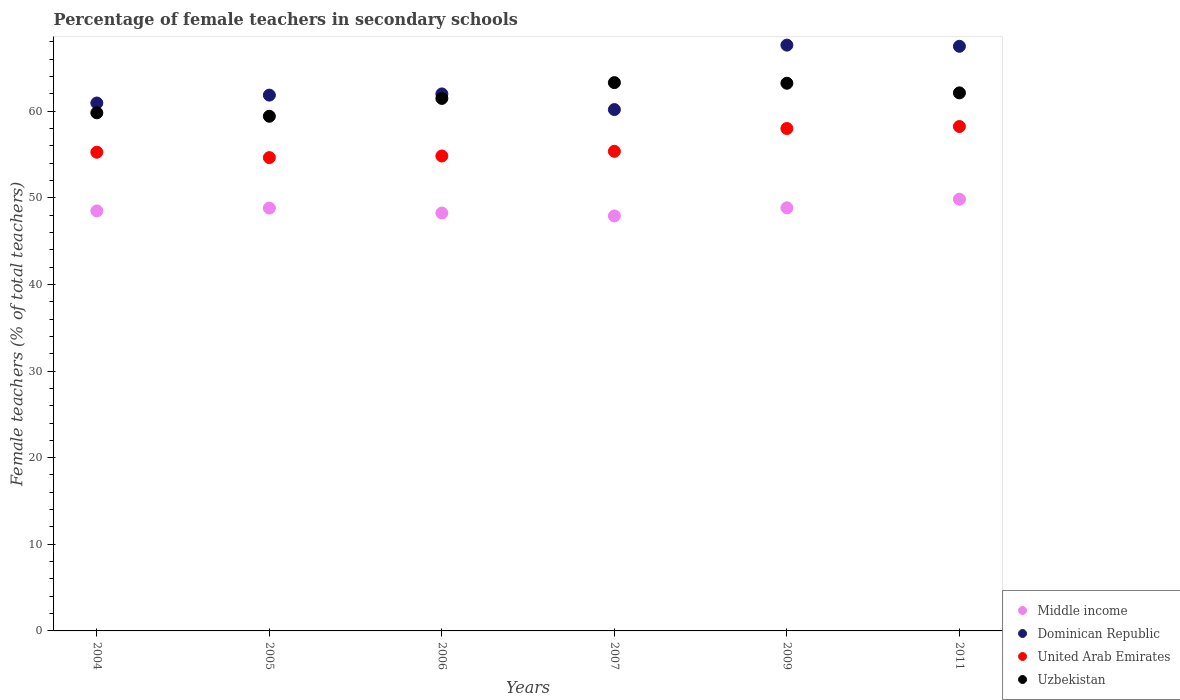How many different coloured dotlines are there?
Your answer should be compact. 4. Is the number of dotlines equal to the number of legend labels?
Your response must be concise. Yes. What is the percentage of female teachers in Middle income in 2007?
Offer a very short reply. 47.9. Across all years, what is the maximum percentage of female teachers in Uzbekistan?
Keep it short and to the point. 63.29. Across all years, what is the minimum percentage of female teachers in Dominican Republic?
Give a very brief answer. 60.18. In which year was the percentage of female teachers in Uzbekistan minimum?
Offer a terse response. 2005. What is the total percentage of female teachers in Uzbekistan in the graph?
Keep it short and to the point. 369.3. What is the difference between the percentage of female teachers in Uzbekistan in 2006 and that in 2007?
Your response must be concise. -1.82. What is the difference between the percentage of female teachers in Dominican Republic in 2011 and the percentage of female teachers in Middle income in 2005?
Make the answer very short. 18.68. What is the average percentage of female teachers in Dominican Republic per year?
Provide a succinct answer. 63.34. In the year 2011, what is the difference between the percentage of female teachers in Middle income and percentage of female teachers in Uzbekistan?
Your response must be concise. -12.27. What is the ratio of the percentage of female teachers in Middle income in 2006 to that in 2009?
Offer a terse response. 0.99. Is the percentage of female teachers in Dominican Republic in 2004 less than that in 2007?
Offer a terse response. No. Is the difference between the percentage of female teachers in Middle income in 2004 and 2011 greater than the difference between the percentage of female teachers in Uzbekistan in 2004 and 2011?
Give a very brief answer. Yes. What is the difference between the highest and the second highest percentage of female teachers in Middle income?
Offer a terse response. 1. What is the difference between the highest and the lowest percentage of female teachers in Dominican Republic?
Provide a succinct answer. 7.44. In how many years, is the percentage of female teachers in Middle income greater than the average percentage of female teachers in Middle income taken over all years?
Make the answer very short. 3. Is it the case that in every year, the sum of the percentage of female teachers in Dominican Republic and percentage of female teachers in United Arab Emirates  is greater than the percentage of female teachers in Middle income?
Your response must be concise. Yes. Does the percentage of female teachers in United Arab Emirates monotonically increase over the years?
Ensure brevity in your answer.  No. How many dotlines are there?
Your answer should be very brief. 4. How many years are there in the graph?
Make the answer very short. 6. What is the difference between two consecutive major ticks on the Y-axis?
Offer a terse response. 10. Does the graph contain any zero values?
Give a very brief answer. No. What is the title of the graph?
Your response must be concise. Percentage of female teachers in secondary schools. What is the label or title of the X-axis?
Ensure brevity in your answer.  Years. What is the label or title of the Y-axis?
Your answer should be very brief. Female teachers (% of total teachers). What is the Female teachers (% of total teachers) of Middle income in 2004?
Your response must be concise. 48.48. What is the Female teachers (% of total teachers) in Dominican Republic in 2004?
Make the answer very short. 60.94. What is the Female teachers (% of total teachers) of United Arab Emirates in 2004?
Make the answer very short. 55.26. What is the Female teachers (% of total teachers) of Uzbekistan in 2004?
Ensure brevity in your answer.  59.81. What is the Female teachers (% of total teachers) in Middle income in 2005?
Offer a very short reply. 48.81. What is the Female teachers (% of total teachers) of Dominican Republic in 2005?
Your response must be concise. 61.85. What is the Female teachers (% of total teachers) of United Arab Emirates in 2005?
Your response must be concise. 54.64. What is the Female teachers (% of total teachers) in Uzbekistan in 2005?
Offer a terse response. 59.41. What is the Female teachers (% of total teachers) in Middle income in 2006?
Provide a succinct answer. 48.24. What is the Female teachers (% of total teachers) in Dominican Republic in 2006?
Offer a terse response. 61.99. What is the Female teachers (% of total teachers) of United Arab Emirates in 2006?
Keep it short and to the point. 54.82. What is the Female teachers (% of total teachers) of Uzbekistan in 2006?
Your response must be concise. 61.47. What is the Female teachers (% of total teachers) of Middle income in 2007?
Provide a short and direct response. 47.9. What is the Female teachers (% of total teachers) in Dominican Republic in 2007?
Offer a terse response. 60.18. What is the Female teachers (% of total teachers) of United Arab Emirates in 2007?
Offer a very short reply. 55.36. What is the Female teachers (% of total teachers) in Uzbekistan in 2007?
Ensure brevity in your answer.  63.29. What is the Female teachers (% of total teachers) in Middle income in 2009?
Provide a short and direct response. 48.84. What is the Female teachers (% of total teachers) of Dominican Republic in 2009?
Provide a short and direct response. 67.62. What is the Female teachers (% of total teachers) in United Arab Emirates in 2009?
Provide a succinct answer. 58. What is the Female teachers (% of total teachers) of Uzbekistan in 2009?
Ensure brevity in your answer.  63.22. What is the Female teachers (% of total teachers) of Middle income in 2011?
Offer a terse response. 49.84. What is the Female teachers (% of total teachers) of Dominican Republic in 2011?
Your answer should be very brief. 67.48. What is the Female teachers (% of total teachers) in United Arab Emirates in 2011?
Give a very brief answer. 58.23. What is the Female teachers (% of total teachers) in Uzbekistan in 2011?
Your response must be concise. 62.11. Across all years, what is the maximum Female teachers (% of total teachers) of Middle income?
Make the answer very short. 49.84. Across all years, what is the maximum Female teachers (% of total teachers) in Dominican Republic?
Ensure brevity in your answer.  67.62. Across all years, what is the maximum Female teachers (% of total teachers) in United Arab Emirates?
Your answer should be compact. 58.23. Across all years, what is the maximum Female teachers (% of total teachers) of Uzbekistan?
Give a very brief answer. 63.29. Across all years, what is the minimum Female teachers (% of total teachers) of Middle income?
Your answer should be very brief. 47.9. Across all years, what is the minimum Female teachers (% of total teachers) of Dominican Republic?
Keep it short and to the point. 60.18. Across all years, what is the minimum Female teachers (% of total teachers) of United Arab Emirates?
Your answer should be compact. 54.64. Across all years, what is the minimum Female teachers (% of total teachers) of Uzbekistan?
Give a very brief answer. 59.41. What is the total Female teachers (% of total teachers) of Middle income in the graph?
Give a very brief answer. 292.1. What is the total Female teachers (% of total teachers) of Dominican Republic in the graph?
Provide a short and direct response. 380.06. What is the total Female teachers (% of total teachers) in United Arab Emirates in the graph?
Keep it short and to the point. 336.3. What is the total Female teachers (% of total teachers) of Uzbekistan in the graph?
Give a very brief answer. 369.3. What is the difference between the Female teachers (% of total teachers) of Middle income in 2004 and that in 2005?
Ensure brevity in your answer.  -0.32. What is the difference between the Female teachers (% of total teachers) of Dominican Republic in 2004 and that in 2005?
Make the answer very short. -0.91. What is the difference between the Female teachers (% of total teachers) in United Arab Emirates in 2004 and that in 2005?
Offer a terse response. 0.62. What is the difference between the Female teachers (% of total teachers) of Uzbekistan in 2004 and that in 2005?
Your answer should be compact. 0.4. What is the difference between the Female teachers (% of total teachers) of Middle income in 2004 and that in 2006?
Your answer should be compact. 0.24. What is the difference between the Female teachers (% of total teachers) of Dominican Republic in 2004 and that in 2006?
Provide a succinct answer. -1.05. What is the difference between the Female teachers (% of total teachers) of United Arab Emirates in 2004 and that in 2006?
Ensure brevity in your answer.  0.44. What is the difference between the Female teachers (% of total teachers) of Uzbekistan in 2004 and that in 2006?
Your answer should be compact. -1.66. What is the difference between the Female teachers (% of total teachers) of Middle income in 2004 and that in 2007?
Offer a terse response. 0.58. What is the difference between the Female teachers (% of total teachers) in Dominican Republic in 2004 and that in 2007?
Make the answer very short. 0.76. What is the difference between the Female teachers (% of total teachers) of United Arab Emirates in 2004 and that in 2007?
Your answer should be compact. -0.1. What is the difference between the Female teachers (% of total teachers) in Uzbekistan in 2004 and that in 2007?
Offer a very short reply. -3.48. What is the difference between the Female teachers (% of total teachers) in Middle income in 2004 and that in 2009?
Provide a succinct answer. -0.36. What is the difference between the Female teachers (% of total teachers) of Dominican Republic in 2004 and that in 2009?
Offer a very short reply. -6.68. What is the difference between the Female teachers (% of total teachers) in United Arab Emirates in 2004 and that in 2009?
Make the answer very short. -2.74. What is the difference between the Female teachers (% of total teachers) of Uzbekistan in 2004 and that in 2009?
Provide a succinct answer. -3.41. What is the difference between the Female teachers (% of total teachers) in Middle income in 2004 and that in 2011?
Provide a short and direct response. -1.35. What is the difference between the Female teachers (% of total teachers) in Dominican Republic in 2004 and that in 2011?
Your answer should be compact. -6.55. What is the difference between the Female teachers (% of total teachers) in United Arab Emirates in 2004 and that in 2011?
Your response must be concise. -2.97. What is the difference between the Female teachers (% of total teachers) in Uzbekistan in 2004 and that in 2011?
Your answer should be compact. -2.3. What is the difference between the Female teachers (% of total teachers) of Middle income in 2005 and that in 2006?
Offer a very short reply. 0.57. What is the difference between the Female teachers (% of total teachers) in Dominican Republic in 2005 and that in 2006?
Provide a short and direct response. -0.14. What is the difference between the Female teachers (% of total teachers) in United Arab Emirates in 2005 and that in 2006?
Offer a very short reply. -0.19. What is the difference between the Female teachers (% of total teachers) in Uzbekistan in 2005 and that in 2006?
Keep it short and to the point. -2.06. What is the difference between the Female teachers (% of total teachers) in Middle income in 2005 and that in 2007?
Your answer should be compact. 0.9. What is the difference between the Female teachers (% of total teachers) of Dominican Republic in 2005 and that in 2007?
Make the answer very short. 1.67. What is the difference between the Female teachers (% of total teachers) in United Arab Emirates in 2005 and that in 2007?
Make the answer very short. -0.73. What is the difference between the Female teachers (% of total teachers) of Uzbekistan in 2005 and that in 2007?
Offer a very short reply. -3.88. What is the difference between the Female teachers (% of total teachers) of Middle income in 2005 and that in 2009?
Keep it short and to the point. -0.03. What is the difference between the Female teachers (% of total teachers) in Dominican Republic in 2005 and that in 2009?
Provide a short and direct response. -5.77. What is the difference between the Female teachers (% of total teachers) of United Arab Emirates in 2005 and that in 2009?
Give a very brief answer. -3.36. What is the difference between the Female teachers (% of total teachers) of Uzbekistan in 2005 and that in 2009?
Your answer should be compact. -3.81. What is the difference between the Female teachers (% of total teachers) of Middle income in 2005 and that in 2011?
Provide a short and direct response. -1.03. What is the difference between the Female teachers (% of total teachers) of Dominican Republic in 2005 and that in 2011?
Offer a very short reply. -5.64. What is the difference between the Female teachers (% of total teachers) in United Arab Emirates in 2005 and that in 2011?
Keep it short and to the point. -3.59. What is the difference between the Female teachers (% of total teachers) in Uzbekistan in 2005 and that in 2011?
Ensure brevity in your answer.  -2.7. What is the difference between the Female teachers (% of total teachers) in Middle income in 2006 and that in 2007?
Ensure brevity in your answer.  0.34. What is the difference between the Female teachers (% of total teachers) in Dominican Republic in 2006 and that in 2007?
Give a very brief answer. 1.81. What is the difference between the Female teachers (% of total teachers) in United Arab Emirates in 2006 and that in 2007?
Your answer should be very brief. -0.54. What is the difference between the Female teachers (% of total teachers) in Uzbekistan in 2006 and that in 2007?
Offer a very short reply. -1.82. What is the difference between the Female teachers (% of total teachers) of Middle income in 2006 and that in 2009?
Give a very brief answer. -0.6. What is the difference between the Female teachers (% of total teachers) in Dominican Republic in 2006 and that in 2009?
Keep it short and to the point. -5.63. What is the difference between the Female teachers (% of total teachers) in United Arab Emirates in 2006 and that in 2009?
Offer a very short reply. -3.17. What is the difference between the Female teachers (% of total teachers) of Uzbekistan in 2006 and that in 2009?
Your response must be concise. -1.75. What is the difference between the Female teachers (% of total teachers) in Middle income in 2006 and that in 2011?
Ensure brevity in your answer.  -1.6. What is the difference between the Female teachers (% of total teachers) in Dominican Republic in 2006 and that in 2011?
Make the answer very short. -5.5. What is the difference between the Female teachers (% of total teachers) in United Arab Emirates in 2006 and that in 2011?
Make the answer very short. -3.4. What is the difference between the Female teachers (% of total teachers) in Uzbekistan in 2006 and that in 2011?
Your answer should be very brief. -0.64. What is the difference between the Female teachers (% of total teachers) of Middle income in 2007 and that in 2009?
Keep it short and to the point. -0.94. What is the difference between the Female teachers (% of total teachers) of Dominican Republic in 2007 and that in 2009?
Your answer should be very brief. -7.44. What is the difference between the Female teachers (% of total teachers) of United Arab Emirates in 2007 and that in 2009?
Offer a very short reply. -2.63. What is the difference between the Female teachers (% of total teachers) in Uzbekistan in 2007 and that in 2009?
Make the answer very short. 0.07. What is the difference between the Female teachers (% of total teachers) of Middle income in 2007 and that in 2011?
Provide a succinct answer. -1.93. What is the difference between the Female teachers (% of total teachers) of Dominican Republic in 2007 and that in 2011?
Provide a short and direct response. -7.3. What is the difference between the Female teachers (% of total teachers) of United Arab Emirates in 2007 and that in 2011?
Provide a short and direct response. -2.86. What is the difference between the Female teachers (% of total teachers) in Uzbekistan in 2007 and that in 2011?
Give a very brief answer. 1.18. What is the difference between the Female teachers (% of total teachers) of Middle income in 2009 and that in 2011?
Make the answer very short. -1. What is the difference between the Female teachers (% of total teachers) of Dominican Republic in 2009 and that in 2011?
Offer a terse response. 0.14. What is the difference between the Female teachers (% of total teachers) in United Arab Emirates in 2009 and that in 2011?
Your answer should be very brief. -0.23. What is the difference between the Female teachers (% of total teachers) in Uzbekistan in 2009 and that in 2011?
Offer a very short reply. 1.11. What is the difference between the Female teachers (% of total teachers) in Middle income in 2004 and the Female teachers (% of total teachers) in Dominican Republic in 2005?
Your answer should be very brief. -13.37. What is the difference between the Female teachers (% of total teachers) of Middle income in 2004 and the Female teachers (% of total teachers) of United Arab Emirates in 2005?
Offer a terse response. -6.15. What is the difference between the Female teachers (% of total teachers) in Middle income in 2004 and the Female teachers (% of total teachers) in Uzbekistan in 2005?
Ensure brevity in your answer.  -10.93. What is the difference between the Female teachers (% of total teachers) in Dominican Republic in 2004 and the Female teachers (% of total teachers) in United Arab Emirates in 2005?
Offer a terse response. 6.3. What is the difference between the Female teachers (% of total teachers) of Dominican Republic in 2004 and the Female teachers (% of total teachers) of Uzbekistan in 2005?
Make the answer very short. 1.53. What is the difference between the Female teachers (% of total teachers) of United Arab Emirates in 2004 and the Female teachers (% of total teachers) of Uzbekistan in 2005?
Your answer should be compact. -4.15. What is the difference between the Female teachers (% of total teachers) in Middle income in 2004 and the Female teachers (% of total teachers) in Dominican Republic in 2006?
Your answer should be very brief. -13.51. What is the difference between the Female teachers (% of total teachers) of Middle income in 2004 and the Female teachers (% of total teachers) of United Arab Emirates in 2006?
Your response must be concise. -6.34. What is the difference between the Female teachers (% of total teachers) in Middle income in 2004 and the Female teachers (% of total teachers) in Uzbekistan in 2006?
Ensure brevity in your answer.  -12.99. What is the difference between the Female teachers (% of total teachers) in Dominican Republic in 2004 and the Female teachers (% of total teachers) in United Arab Emirates in 2006?
Your answer should be very brief. 6.11. What is the difference between the Female teachers (% of total teachers) in Dominican Republic in 2004 and the Female teachers (% of total teachers) in Uzbekistan in 2006?
Give a very brief answer. -0.53. What is the difference between the Female teachers (% of total teachers) of United Arab Emirates in 2004 and the Female teachers (% of total teachers) of Uzbekistan in 2006?
Your answer should be very brief. -6.21. What is the difference between the Female teachers (% of total teachers) in Middle income in 2004 and the Female teachers (% of total teachers) in Dominican Republic in 2007?
Offer a very short reply. -11.7. What is the difference between the Female teachers (% of total teachers) in Middle income in 2004 and the Female teachers (% of total teachers) in United Arab Emirates in 2007?
Offer a very short reply. -6.88. What is the difference between the Female teachers (% of total teachers) in Middle income in 2004 and the Female teachers (% of total teachers) in Uzbekistan in 2007?
Keep it short and to the point. -14.81. What is the difference between the Female teachers (% of total teachers) in Dominican Republic in 2004 and the Female teachers (% of total teachers) in United Arab Emirates in 2007?
Keep it short and to the point. 5.58. What is the difference between the Female teachers (% of total teachers) in Dominican Republic in 2004 and the Female teachers (% of total teachers) in Uzbekistan in 2007?
Your answer should be very brief. -2.35. What is the difference between the Female teachers (% of total teachers) in United Arab Emirates in 2004 and the Female teachers (% of total teachers) in Uzbekistan in 2007?
Make the answer very short. -8.03. What is the difference between the Female teachers (% of total teachers) of Middle income in 2004 and the Female teachers (% of total teachers) of Dominican Republic in 2009?
Offer a very short reply. -19.14. What is the difference between the Female teachers (% of total teachers) in Middle income in 2004 and the Female teachers (% of total teachers) in United Arab Emirates in 2009?
Your response must be concise. -9.51. What is the difference between the Female teachers (% of total teachers) of Middle income in 2004 and the Female teachers (% of total teachers) of Uzbekistan in 2009?
Make the answer very short. -14.74. What is the difference between the Female teachers (% of total teachers) of Dominican Republic in 2004 and the Female teachers (% of total teachers) of United Arab Emirates in 2009?
Ensure brevity in your answer.  2.94. What is the difference between the Female teachers (% of total teachers) in Dominican Republic in 2004 and the Female teachers (% of total teachers) in Uzbekistan in 2009?
Provide a short and direct response. -2.28. What is the difference between the Female teachers (% of total teachers) of United Arab Emirates in 2004 and the Female teachers (% of total teachers) of Uzbekistan in 2009?
Offer a very short reply. -7.96. What is the difference between the Female teachers (% of total teachers) of Middle income in 2004 and the Female teachers (% of total teachers) of Dominican Republic in 2011?
Provide a short and direct response. -19. What is the difference between the Female teachers (% of total teachers) in Middle income in 2004 and the Female teachers (% of total teachers) in United Arab Emirates in 2011?
Give a very brief answer. -9.74. What is the difference between the Female teachers (% of total teachers) in Middle income in 2004 and the Female teachers (% of total teachers) in Uzbekistan in 2011?
Ensure brevity in your answer.  -13.63. What is the difference between the Female teachers (% of total teachers) in Dominican Republic in 2004 and the Female teachers (% of total teachers) in United Arab Emirates in 2011?
Offer a very short reply. 2.71. What is the difference between the Female teachers (% of total teachers) of Dominican Republic in 2004 and the Female teachers (% of total teachers) of Uzbekistan in 2011?
Make the answer very short. -1.17. What is the difference between the Female teachers (% of total teachers) of United Arab Emirates in 2004 and the Female teachers (% of total teachers) of Uzbekistan in 2011?
Offer a terse response. -6.85. What is the difference between the Female teachers (% of total teachers) of Middle income in 2005 and the Female teachers (% of total teachers) of Dominican Republic in 2006?
Provide a short and direct response. -13.18. What is the difference between the Female teachers (% of total teachers) of Middle income in 2005 and the Female teachers (% of total teachers) of United Arab Emirates in 2006?
Ensure brevity in your answer.  -6.02. What is the difference between the Female teachers (% of total teachers) of Middle income in 2005 and the Female teachers (% of total teachers) of Uzbekistan in 2006?
Provide a succinct answer. -12.66. What is the difference between the Female teachers (% of total teachers) in Dominican Republic in 2005 and the Female teachers (% of total teachers) in United Arab Emirates in 2006?
Your answer should be very brief. 7.03. What is the difference between the Female teachers (% of total teachers) in Dominican Republic in 2005 and the Female teachers (% of total teachers) in Uzbekistan in 2006?
Make the answer very short. 0.38. What is the difference between the Female teachers (% of total teachers) in United Arab Emirates in 2005 and the Female teachers (% of total teachers) in Uzbekistan in 2006?
Offer a very short reply. -6.83. What is the difference between the Female teachers (% of total teachers) of Middle income in 2005 and the Female teachers (% of total teachers) of Dominican Republic in 2007?
Offer a terse response. -11.37. What is the difference between the Female teachers (% of total teachers) of Middle income in 2005 and the Female teachers (% of total teachers) of United Arab Emirates in 2007?
Provide a short and direct response. -6.56. What is the difference between the Female teachers (% of total teachers) in Middle income in 2005 and the Female teachers (% of total teachers) in Uzbekistan in 2007?
Offer a very short reply. -14.48. What is the difference between the Female teachers (% of total teachers) in Dominican Republic in 2005 and the Female teachers (% of total teachers) in United Arab Emirates in 2007?
Your response must be concise. 6.49. What is the difference between the Female teachers (% of total teachers) in Dominican Republic in 2005 and the Female teachers (% of total teachers) in Uzbekistan in 2007?
Make the answer very short. -1.44. What is the difference between the Female teachers (% of total teachers) in United Arab Emirates in 2005 and the Female teachers (% of total teachers) in Uzbekistan in 2007?
Make the answer very short. -8.65. What is the difference between the Female teachers (% of total teachers) in Middle income in 2005 and the Female teachers (% of total teachers) in Dominican Republic in 2009?
Ensure brevity in your answer.  -18.81. What is the difference between the Female teachers (% of total teachers) in Middle income in 2005 and the Female teachers (% of total teachers) in United Arab Emirates in 2009?
Offer a terse response. -9.19. What is the difference between the Female teachers (% of total teachers) in Middle income in 2005 and the Female teachers (% of total teachers) in Uzbekistan in 2009?
Keep it short and to the point. -14.41. What is the difference between the Female teachers (% of total teachers) in Dominican Republic in 2005 and the Female teachers (% of total teachers) in United Arab Emirates in 2009?
Offer a terse response. 3.85. What is the difference between the Female teachers (% of total teachers) in Dominican Republic in 2005 and the Female teachers (% of total teachers) in Uzbekistan in 2009?
Your answer should be very brief. -1.37. What is the difference between the Female teachers (% of total teachers) of United Arab Emirates in 2005 and the Female teachers (% of total teachers) of Uzbekistan in 2009?
Ensure brevity in your answer.  -8.58. What is the difference between the Female teachers (% of total teachers) of Middle income in 2005 and the Female teachers (% of total teachers) of Dominican Republic in 2011?
Make the answer very short. -18.68. What is the difference between the Female teachers (% of total teachers) of Middle income in 2005 and the Female teachers (% of total teachers) of United Arab Emirates in 2011?
Provide a short and direct response. -9.42. What is the difference between the Female teachers (% of total teachers) of Middle income in 2005 and the Female teachers (% of total teachers) of Uzbekistan in 2011?
Provide a succinct answer. -13.3. What is the difference between the Female teachers (% of total teachers) in Dominican Republic in 2005 and the Female teachers (% of total teachers) in United Arab Emirates in 2011?
Ensure brevity in your answer.  3.62. What is the difference between the Female teachers (% of total teachers) of Dominican Republic in 2005 and the Female teachers (% of total teachers) of Uzbekistan in 2011?
Provide a short and direct response. -0.26. What is the difference between the Female teachers (% of total teachers) in United Arab Emirates in 2005 and the Female teachers (% of total teachers) in Uzbekistan in 2011?
Provide a short and direct response. -7.47. What is the difference between the Female teachers (% of total teachers) of Middle income in 2006 and the Female teachers (% of total teachers) of Dominican Republic in 2007?
Offer a very short reply. -11.94. What is the difference between the Female teachers (% of total teachers) in Middle income in 2006 and the Female teachers (% of total teachers) in United Arab Emirates in 2007?
Give a very brief answer. -7.12. What is the difference between the Female teachers (% of total teachers) in Middle income in 2006 and the Female teachers (% of total teachers) in Uzbekistan in 2007?
Your answer should be very brief. -15.05. What is the difference between the Female teachers (% of total teachers) of Dominican Republic in 2006 and the Female teachers (% of total teachers) of United Arab Emirates in 2007?
Your answer should be compact. 6.63. What is the difference between the Female teachers (% of total teachers) in Dominican Republic in 2006 and the Female teachers (% of total teachers) in Uzbekistan in 2007?
Offer a terse response. -1.3. What is the difference between the Female teachers (% of total teachers) of United Arab Emirates in 2006 and the Female teachers (% of total teachers) of Uzbekistan in 2007?
Your answer should be very brief. -8.47. What is the difference between the Female teachers (% of total teachers) in Middle income in 2006 and the Female teachers (% of total teachers) in Dominican Republic in 2009?
Your answer should be very brief. -19.38. What is the difference between the Female teachers (% of total teachers) of Middle income in 2006 and the Female teachers (% of total teachers) of United Arab Emirates in 2009?
Provide a succinct answer. -9.76. What is the difference between the Female teachers (% of total teachers) of Middle income in 2006 and the Female teachers (% of total teachers) of Uzbekistan in 2009?
Provide a short and direct response. -14.98. What is the difference between the Female teachers (% of total teachers) of Dominican Republic in 2006 and the Female teachers (% of total teachers) of United Arab Emirates in 2009?
Your answer should be compact. 3.99. What is the difference between the Female teachers (% of total teachers) in Dominican Republic in 2006 and the Female teachers (% of total teachers) in Uzbekistan in 2009?
Your response must be concise. -1.23. What is the difference between the Female teachers (% of total teachers) of United Arab Emirates in 2006 and the Female teachers (% of total teachers) of Uzbekistan in 2009?
Keep it short and to the point. -8.4. What is the difference between the Female teachers (% of total teachers) of Middle income in 2006 and the Female teachers (% of total teachers) of Dominican Republic in 2011?
Offer a terse response. -19.24. What is the difference between the Female teachers (% of total teachers) of Middle income in 2006 and the Female teachers (% of total teachers) of United Arab Emirates in 2011?
Offer a terse response. -9.99. What is the difference between the Female teachers (% of total teachers) of Middle income in 2006 and the Female teachers (% of total teachers) of Uzbekistan in 2011?
Offer a terse response. -13.87. What is the difference between the Female teachers (% of total teachers) of Dominican Republic in 2006 and the Female teachers (% of total teachers) of United Arab Emirates in 2011?
Provide a short and direct response. 3.76. What is the difference between the Female teachers (% of total teachers) in Dominican Republic in 2006 and the Female teachers (% of total teachers) in Uzbekistan in 2011?
Provide a succinct answer. -0.12. What is the difference between the Female teachers (% of total teachers) in United Arab Emirates in 2006 and the Female teachers (% of total teachers) in Uzbekistan in 2011?
Your answer should be very brief. -7.29. What is the difference between the Female teachers (% of total teachers) of Middle income in 2007 and the Female teachers (% of total teachers) of Dominican Republic in 2009?
Provide a short and direct response. -19.72. What is the difference between the Female teachers (% of total teachers) in Middle income in 2007 and the Female teachers (% of total teachers) in United Arab Emirates in 2009?
Keep it short and to the point. -10.09. What is the difference between the Female teachers (% of total teachers) in Middle income in 2007 and the Female teachers (% of total teachers) in Uzbekistan in 2009?
Ensure brevity in your answer.  -15.32. What is the difference between the Female teachers (% of total teachers) of Dominican Republic in 2007 and the Female teachers (% of total teachers) of United Arab Emirates in 2009?
Provide a succinct answer. 2.18. What is the difference between the Female teachers (% of total teachers) in Dominican Republic in 2007 and the Female teachers (% of total teachers) in Uzbekistan in 2009?
Offer a terse response. -3.04. What is the difference between the Female teachers (% of total teachers) in United Arab Emirates in 2007 and the Female teachers (% of total teachers) in Uzbekistan in 2009?
Keep it short and to the point. -7.86. What is the difference between the Female teachers (% of total teachers) in Middle income in 2007 and the Female teachers (% of total teachers) in Dominican Republic in 2011?
Provide a succinct answer. -19.58. What is the difference between the Female teachers (% of total teachers) of Middle income in 2007 and the Female teachers (% of total teachers) of United Arab Emirates in 2011?
Give a very brief answer. -10.32. What is the difference between the Female teachers (% of total teachers) of Middle income in 2007 and the Female teachers (% of total teachers) of Uzbekistan in 2011?
Ensure brevity in your answer.  -14.21. What is the difference between the Female teachers (% of total teachers) of Dominican Republic in 2007 and the Female teachers (% of total teachers) of United Arab Emirates in 2011?
Make the answer very short. 1.95. What is the difference between the Female teachers (% of total teachers) of Dominican Republic in 2007 and the Female teachers (% of total teachers) of Uzbekistan in 2011?
Offer a terse response. -1.93. What is the difference between the Female teachers (% of total teachers) in United Arab Emirates in 2007 and the Female teachers (% of total teachers) in Uzbekistan in 2011?
Provide a succinct answer. -6.75. What is the difference between the Female teachers (% of total teachers) in Middle income in 2009 and the Female teachers (% of total teachers) in Dominican Republic in 2011?
Your answer should be very brief. -18.64. What is the difference between the Female teachers (% of total teachers) of Middle income in 2009 and the Female teachers (% of total teachers) of United Arab Emirates in 2011?
Provide a succinct answer. -9.39. What is the difference between the Female teachers (% of total teachers) of Middle income in 2009 and the Female teachers (% of total teachers) of Uzbekistan in 2011?
Your answer should be compact. -13.27. What is the difference between the Female teachers (% of total teachers) in Dominican Republic in 2009 and the Female teachers (% of total teachers) in United Arab Emirates in 2011?
Ensure brevity in your answer.  9.39. What is the difference between the Female teachers (% of total teachers) in Dominican Republic in 2009 and the Female teachers (% of total teachers) in Uzbekistan in 2011?
Offer a terse response. 5.51. What is the difference between the Female teachers (% of total teachers) of United Arab Emirates in 2009 and the Female teachers (% of total teachers) of Uzbekistan in 2011?
Your answer should be very brief. -4.11. What is the average Female teachers (% of total teachers) in Middle income per year?
Offer a terse response. 48.68. What is the average Female teachers (% of total teachers) of Dominican Republic per year?
Keep it short and to the point. 63.34. What is the average Female teachers (% of total teachers) in United Arab Emirates per year?
Make the answer very short. 56.05. What is the average Female teachers (% of total teachers) in Uzbekistan per year?
Make the answer very short. 61.55. In the year 2004, what is the difference between the Female teachers (% of total teachers) of Middle income and Female teachers (% of total teachers) of Dominican Republic?
Your response must be concise. -12.45. In the year 2004, what is the difference between the Female teachers (% of total teachers) of Middle income and Female teachers (% of total teachers) of United Arab Emirates?
Your response must be concise. -6.78. In the year 2004, what is the difference between the Female teachers (% of total teachers) of Middle income and Female teachers (% of total teachers) of Uzbekistan?
Offer a terse response. -11.32. In the year 2004, what is the difference between the Female teachers (% of total teachers) in Dominican Republic and Female teachers (% of total teachers) in United Arab Emirates?
Your response must be concise. 5.68. In the year 2004, what is the difference between the Female teachers (% of total teachers) of Dominican Republic and Female teachers (% of total teachers) of Uzbekistan?
Your answer should be very brief. 1.13. In the year 2004, what is the difference between the Female teachers (% of total teachers) in United Arab Emirates and Female teachers (% of total teachers) in Uzbekistan?
Offer a terse response. -4.55. In the year 2005, what is the difference between the Female teachers (% of total teachers) of Middle income and Female teachers (% of total teachers) of Dominican Republic?
Provide a succinct answer. -13.04. In the year 2005, what is the difference between the Female teachers (% of total teachers) in Middle income and Female teachers (% of total teachers) in United Arab Emirates?
Provide a short and direct response. -5.83. In the year 2005, what is the difference between the Female teachers (% of total teachers) in Middle income and Female teachers (% of total teachers) in Uzbekistan?
Your response must be concise. -10.6. In the year 2005, what is the difference between the Female teachers (% of total teachers) in Dominican Republic and Female teachers (% of total teachers) in United Arab Emirates?
Your answer should be compact. 7.21. In the year 2005, what is the difference between the Female teachers (% of total teachers) of Dominican Republic and Female teachers (% of total teachers) of Uzbekistan?
Provide a short and direct response. 2.44. In the year 2005, what is the difference between the Female teachers (% of total teachers) of United Arab Emirates and Female teachers (% of total teachers) of Uzbekistan?
Provide a succinct answer. -4.77. In the year 2006, what is the difference between the Female teachers (% of total teachers) of Middle income and Female teachers (% of total teachers) of Dominican Republic?
Provide a succinct answer. -13.75. In the year 2006, what is the difference between the Female teachers (% of total teachers) of Middle income and Female teachers (% of total teachers) of United Arab Emirates?
Offer a terse response. -6.58. In the year 2006, what is the difference between the Female teachers (% of total teachers) of Middle income and Female teachers (% of total teachers) of Uzbekistan?
Offer a terse response. -13.23. In the year 2006, what is the difference between the Female teachers (% of total teachers) of Dominican Republic and Female teachers (% of total teachers) of United Arab Emirates?
Your response must be concise. 7.17. In the year 2006, what is the difference between the Female teachers (% of total teachers) in Dominican Republic and Female teachers (% of total teachers) in Uzbekistan?
Provide a succinct answer. 0.52. In the year 2006, what is the difference between the Female teachers (% of total teachers) of United Arab Emirates and Female teachers (% of total teachers) of Uzbekistan?
Give a very brief answer. -6.65. In the year 2007, what is the difference between the Female teachers (% of total teachers) in Middle income and Female teachers (% of total teachers) in Dominican Republic?
Your response must be concise. -12.28. In the year 2007, what is the difference between the Female teachers (% of total teachers) of Middle income and Female teachers (% of total teachers) of United Arab Emirates?
Your response must be concise. -7.46. In the year 2007, what is the difference between the Female teachers (% of total teachers) of Middle income and Female teachers (% of total teachers) of Uzbekistan?
Your response must be concise. -15.39. In the year 2007, what is the difference between the Female teachers (% of total teachers) in Dominican Republic and Female teachers (% of total teachers) in United Arab Emirates?
Provide a short and direct response. 4.82. In the year 2007, what is the difference between the Female teachers (% of total teachers) of Dominican Republic and Female teachers (% of total teachers) of Uzbekistan?
Offer a terse response. -3.11. In the year 2007, what is the difference between the Female teachers (% of total teachers) of United Arab Emirates and Female teachers (% of total teachers) of Uzbekistan?
Provide a short and direct response. -7.93. In the year 2009, what is the difference between the Female teachers (% of total teachers) in Middle income and Female teachers (% of total teachers) in Dominican Republic?
Offer a terse response. -18.78. In the year 2009, what is the difference between the Female teachers (% of total teachers) in Middle income and Female teachers (% of total teachers) in United Arab Emirates?
Provide a succinct answer. -9.15. In the year 2009, what is the difference between the Female teachers (% of total teachers) of Middle income and Female teachers (% of total teachers) of Uzbekistan?
Ensure brevity in your answer.  -14.38. In the year 2009, what is the difference between the Female teachers (% of total teachers) in Dominican Republic and Female teachers (% of total teachers) in United Arab Emirates?
Provide a short and direct response. 9.63. In the year 2009, what is the difference between the Female teachers (% of total teachers) of Dominican Republic and Female teachers (% of total teachers) of Uzbekistan?
Provide a succinct answer. 4.4. In the year 2009, what is the difference between the Female teachers (% of total teachers) in United Arab Emirates and Female teachers (% of total teachers) in Uzbekistan?
Your response must be concise. -5.23. In the year 2011, what is the difference between the Female teachers (% of total teachers) of Middle income and Female teachers (% of total teachers) of Dominican Republic?
Ensure brevity in your answer.  -17.65. In the year 2011, what is the difference between the Female teachers (% of total teachers) in Middle income and Female teachers (% of total teachers) in United Arab Emirates?
Ensure brevity in your answer.  -8.39. In the year 2011, what is the difference between the Female teachers (% of total teachers) of Middle income and Female teachers (% of total teachers) of Uzbekistan?
Provide a succinct answer. -12.27. In the year 2011, what is the difference between the Female teachers (% of total teachers) of Dominican Republic and Female teachers (% of total teachers) of United Arab Emirates?
Ensure brevity in your answer.  9.26. In the year 2011, what is the difference between the Female teachers (% of total teachers) in Dominican Republic and Female teachers (% of total teachers) in Uzbekistan?
Your response must be concise. 5.38. In the year 2011, what is the difference between the Female teachers (% of total teachers) in United Arab Emirates and Female teachers (% of total teachers) in Uzbekistan?
Provide a short and direct response. -3.88. What is the ratio of the Female teachers (% of total teachers) of Dominican Republic in 2004 to that in 2005?
Offer a very short reply. 0.99. What is the ratio of the Female teachers (% of total teachers) in United Arab Emirates in 2004 to that in 2005?
Offer a very short reply. 1.01. What is the ratio of the Female teachers (% of total teachers) in Dominican Republic in 2004 to that in 2006?
Offer a terse response. 0.98. What is the ratio of the Female teachers (% of total teachers) in United Arab Emirates in 2004 to that in 2006?
Offer a very short reply. 1.01. What is the ratio of the Female teachers (% of total teachers) of Uzbekistan in 2004 to that in 2006?
Provide a short and direct response. 0.97. What is the ratio of the Female teachers (% of total teachers) of Middle income in 2004 to that in 2007?
Ensure brevity in your answer.  1.01. What is the ratio of the Female teachers (% of total teachers) of Dominican Republic in 2004 to that in 2007?
Offer a terse response. 1.01. What is the ratio of the Female teachers (% of total teachers) of Uzbekistan in 2004 to that in 2007?
Offer a terse response. 0.94. What is the ratio of the Female teachers (% of total teachers) in Dominican Republic in 2004 to that in 2009?
Offer a terse response. 0.9. What is the ratio of the Female teachers (% of total teachers) of United Arab Emirates in 2004 to that in 2009?
Offer a very short reply. 0.95. What is the ratio of the Female teachers (% of total teachers) of Uzbekistan in 2004 to that in 2009?
Offer a very short reply. 0.95. What is the ratio of the Female teachers (% of total teachers) in Middle income in 2004 to that in 2011?
Ensure brevity in your answer.  0.97. What is the ratio of the Female teachers (% of total teachers) in Dominican Republic in 2004 to that in 2011?
Provide a short and direct response. 0.9. What is the ratio of the Female teachers (% of total teachers) in United Arab Emirates in 2004 to that in 2011?
Provide a short and direct response. 0.95. What is the ratio of the Female teachers (% of total teachers) of Uzbekistan in 2004 to that in 2011?
Offer a very short reply. 0.96. What is the ratio of the Female teachers (% of total teachers) in Middle income in 2005 to that in 2006?
Your answer should be very brief. 1.01. What is the ratio of the Female teachers (% of total teachers) in United Arab Emirates in 2005 to that in 2006?
Keep it short and to the point. 1. What is the ratio of the Female teachers (% of total teachers) in Uzbekistan in 2005 to that in 2006?
Your answer should be compact. 0.97. What is the ratio of the Female teachers (% of total teachers) in Middle income in 2005 to that in 2007?
Your response must be concise. 1.02. What is the ratio of the Female teachers (% of total teachers) in Dominican Republic in 2005 to that in 2007?
Make the answer very short. 1.03. What is the ratio of the Female teachers (% of total teachers) in United Arab Emirates in 2005 to that in 2007?
Your answer should be very brief. 0.99. What is the ratio of the Female teachers (% of total teachers) of Uzbekistan in 2005 to that in 2007?
Make the answer very short. 0.94. What is the ratio of the Female teachers (% of total teachers) of Middle income in 2005 to that in 2009?
Your answer should be compact. 1. What is the ratio of the Female teachers (% of total teachers) of Dominican Republic in 2005 to that in 2009?
Keep it short and to the point. 0.91. What is the ratio of the Female teachers (% of total teachers) in United Arab Emirates in 2005 to that in 2009?
Offer a very short reply. 0.94. What is the ratio of the Female teachers (% of total teachers) of Uzbekistan in 2005 to that in 2009?
Provide a short and direct response. 0.94. What is the ratio of the Female teachers (% of total teachers) of Middle income in 2005 to that in 2011?
Provide a short and direct response. 0.98. What is the ratio of the Female teachers (% of total teachers) of Dominican Republic in 2005 to that in 2011?
Your answer should be compact. 0.92. What is the ratio of the Female teachers (% of total teachers) in United Arab Emirates in 2005 to that in 2011?
Make the answer very short. 0.94. What is the ratio of the Female teachers (% of total teachers) of Uzbekistan in 2005 to that in 2011?
Offer a terse response. 0.96. What is the ratio of the Female teachers (% of total teachers) of United Arab Emirates in 2006 to that in 2007?
Offer a very short reply. 0.99. What is the ratio of the Female teachers (% of total teachers) of Uzbekistan in 2006 to that in 2007?
Offer a terse response. 0.97. What is the ratio of the Female teachers (% of total teachers) in Middle income in 2006 to that in 2009?
Ensure brevity in your answer.  0.99. What is the ratio of the Female teachers (% of total teachers) of United Arab Emirates in 2006 to that in 2009?
Give a very brief answer. 0.95. What is the ratio of the Female teachers (% of total teachers) of Uzbekistan in 2006 to that in 2009?
Offer a very short reply. 0.97. What is the ratio of the Female teachers (% of total teachers) of Dominican Republic in 2006 to that in 2011?
Ensure brevity in your answer.  0.92. What is the ratio of the Female teachers (% of total teachers) in United Arab Emirates in 2006 to that in 2011?
Your response must be concise. 0.94. What is the ratio of the Female teachers (% of total teachers) in Uzbekistan in 2006 to that in 2011?
Your answer should be compact. 0.99. What is the ratio of the Female teachers (% of total teachers) in Middle income in 2007 to that in 2009?
Your answer should be very brief. 0.98. What is the ratio of the Female teachers (% of total teachers) in Dominican Republic in 2007 to that in 2009?
Ensure brevity in your answer.  0.89. What is the ratio of the Female teachers (% of total teachers) in United Arab Emirates in 2007 to that in 2009?
Offer a terse response. 0.95. What is the ratio of the Female teachers (% of total teachers) of Uzbekistan in 2007 to that in 2009?
Ensure brevity in your answer.  1. What is the ratio of the Female teachers (% of total teachers) of Middle income in 2007 to that in 2011?
Your response must be concise. 0.96. What is the ratio of the Female teachers (% of total teachers) in Dominican Republic in 2007 to that in 2011?
Your answer should be very brief. 0.89. What is the ratio of the Female teachers (% of total teachers) of United Arab Emirates in 2007 to that in 2011?
Give a very brief answer. 0.95. What is the ratio of the Female teachers (% of total teachers) of Middle income in 2009 to that in 2011?
Provide a succinct answer. 0.98. What is the ratio of the Female teachers (% of total teachers) in Uzbekistan in 2009 to that in 2011?
Your response must be concise. 1.02. What is the difference between the highest and the second highest Female teachers (% of total teachers) of Middle income?
Give a very brief answer. 1. What is the difference between the highest and the second highest Female teachers (% of total teachers) of Dominican Republic?
Keep it short and to the point. 0.14. What is the difference between the highest and the second highest Female teachers (% of total teachers) of United Arab Emirates?
Your response must be concise. 0.23. What is the difference between the highest and the second highest Female teachers (% of total teachers) in Uzbekistan?
Provide a succinct answer. 0.07. What is the difference between the highest and the lowest Female teachers (% of total teachers) in Middle income?
Offer a very short reply. 1.93. What is the difference between the highest and the lowest Female teachers (% of total teachers) in Dominican Republic?
Keep it short and to the point. 7.44. What is the difference between the highest and the lowest Female teachers (% of total teachers) of United Arab Emirates?
Offer a terse response. 3.59. What is the difference between the highest and the lowest Female teachers (% of total teachers) of Uzbekistan?
Your answer should be compact. 3.88. 